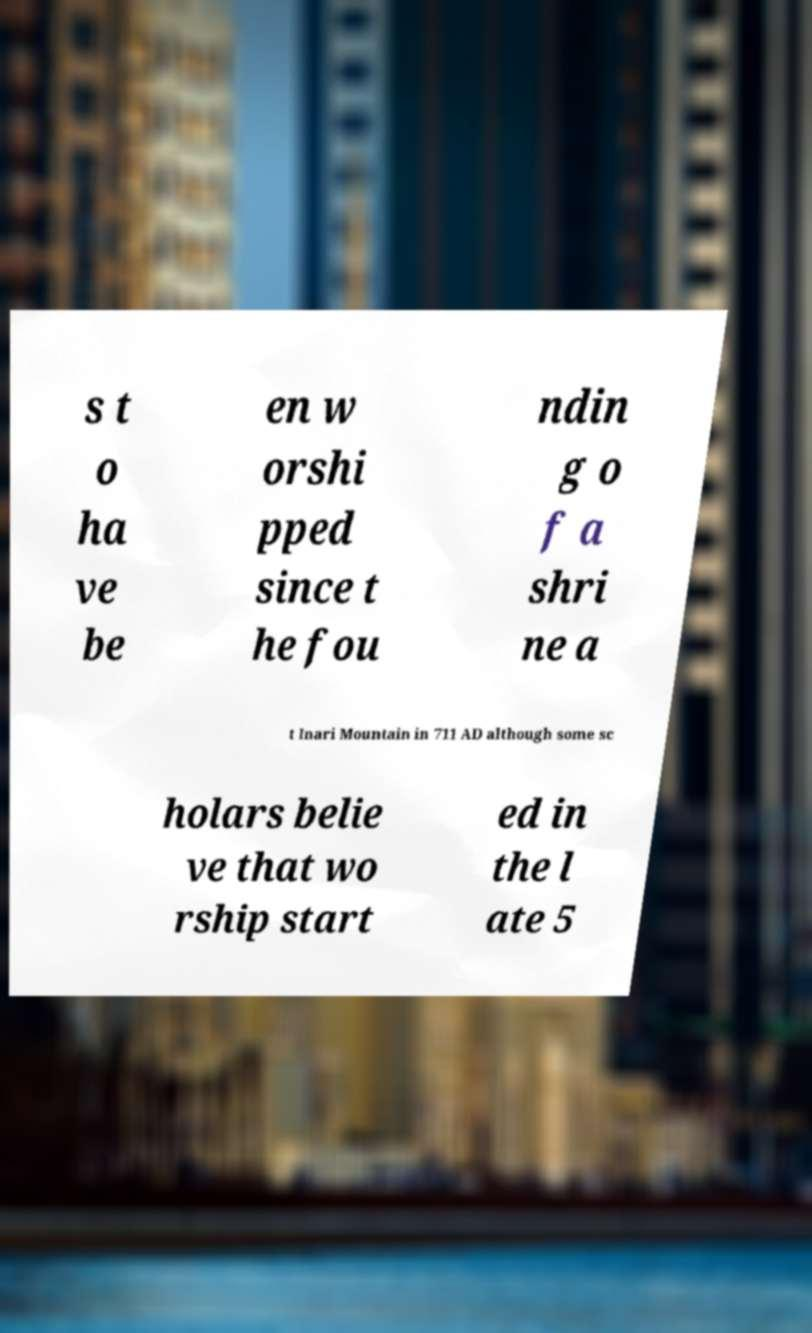Could you assist in decoding the text presented in this image and type it out clearly? s t o ha ve be en w orshi pped since t he fou ndin g o f a shri ne a t Inari Mountain in 711 AD although some sc holars belie ve that wo rship start ed in the l ate 5 